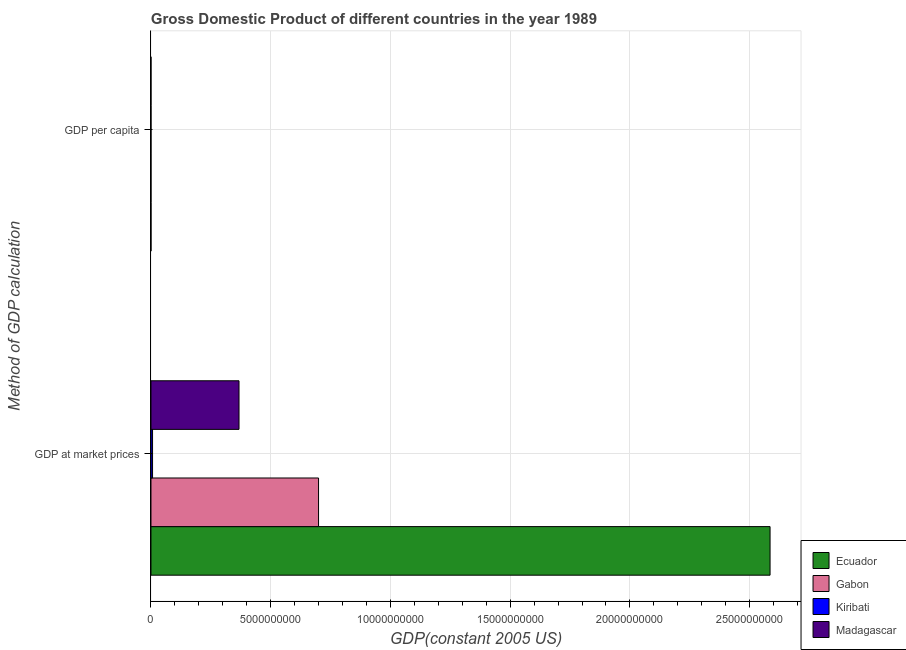How many groups of bars are there?
Make the answer very short. 2. Are the number of bars per tick equal to the number of legend labels?
Keep it short and to the point. Yes. What is the label of the 2nd group of bars from the top?
Your answer should be compact. GDP at market prices. What is the gdp at market prices in Madagascar?
Make the answer very short. 3.68e+09. Across all countries, what is the maximum gdp per capita?
Offer a terse response. 7552.38. Across all countries, what is the minimum gdp at market prices?
Give a very brief answer. 6.62e+07. In which country was the gdp at market prices maximum?
Your answer should be very brief. Ecuador. In which country was the gdp at market prices minimum?
Make the answer very short. Kiribati. What is the total gdp at market prices in the graph?
Your answer should be compact. 3.66e+1. What is the difference between the gdp per capita in Madagascar and that in Ecuador?
Your answer should be very brief. -2262.99. What is the difference between the gdp at market prices in Madagascar and the gdp per capita in Kiribati?
Give a very brief answer. 3.68e+09. What is the average gdp at market prices per country?
Your answer should be very brief. 9.15e+09. What is the difference between the gdp at market prices and gdp per capita in Gabon?
Keep it short and to the point. 7.00e+09. What is the ratio of the gdp per capita in Ecuador to that in Gabon?
Offer a terse response. 0.34. Is the gdp per capita in Madagascar less than that in Kiribati?
Provide a short and direct response. Yes. In how many countries, is the gdp per capita greater than the average gdp per capita taken over all countries?
Provide a short and direct response. 1. What does the 3rd bar from the top in GDP at market prices represents?
Your answer should be compact. Gabon. What does the 2nd bar from the bottom in GDP per capita represents?
Keep it short and to the point. Gabon. How many bars are there?
Your response must be concise. 8. Are all the bars in the graph horizontal?
Offer a terse response. Yes. What is the difference between two consecutive major ticks on the X-axis?
Make the answer very short. 5.00e+09. Are the values on the major ticks of X-axis written in scientific E-notation?
Your answer should be compact. No. Does the graph contain any zero values?
Give a very brief answer. No. Where does the legend appear in the graph?
Your answer should be very brief. Bottom right. How are the legend labels stacked?
Provide a succinct answer. Vertical. What is the title of the graph?
Provide a succinct answer. Gross Domestic Product of different countries in the year 1989. What is the label or title of the X-axis?
Offer a very short reply. GDP(constant 2005 US). What is the label or title of the Y-axis?
Offer a very short reply. Method of GDP calculation. What is the GDP(constant 2005 US) of Ecuador in GDP at market prices?
Your answer should be very brief. 2.59e+1. What is the GDP(constant 2005 US) in Gabon in GDP at market prices?
Offer a terse response. 7.00e+09. What is the GDP(constant 2005 US) in Kiribati in GDP at market prices?
Make the answer very short. 6.62e+07. What is the GDP(constant 2005 US) in Madagascar in GDP at market prices?
Ensure brevity in your answer.  3.68e+09. What is the GDP(constant 2005 US) in Ecuador in GDP per capita?
Give a very brief answer. 2591.15. What is the GDP(constant 2005 US) in Gabon in GDP per capita?
Provide a short and direct response. 7552.38. What is the GDP(constant 2005 US) of Kiribati in GDP per capita?
Your response must be concise. 934.01. What is the GDP(constant 2005 US) of Madagascar in GDP per capita?
Offer a terse response. 328.16. Across all Method of GDP calculation, what is the maximum GDP(constant 2005 US) of Ecuador?
Provide a succinct answer. 2.59e+1. Across all Method of GDP calculation, what is the maximum GDP(constant 2005 US) of Gabon?
Provide a short and direct response. 7.00e+09. Across all Method of GDP calculation, what is the maximum GDP(constant 2005 US) of Kiribati?
Ensure brevity in your answer.  6.62e+07. Across all Method of GDP calculation, what is the maximum GDP(constant 2005 US) in Madagascar?
Ensure brevity in your answer.  3.68e+09. Across all Method of GDP calculation, what is the minimum GDP(constant 2005 US) in Ecuador?
Offer a terse response. 2591.15. Across all Method of GDP calculation, what is the minimum GDP(constant 2005 US) in Gabon?
Keep it short and to the point. 7552.38. Across all Method of GDP calculation, what is the minimum GDP(constant 2005 US) of Kiribati?
Provide a succinct answer. 934.01. Across all Method of GDP calculation, what is the minimum GDP(constant 2005 US) in Madagascar?
Your answer should be compact. 328.16. What is the total GDP(constant 2005 US) of Ecuador in the graph?
Give a very brief answer. 2.59e+1. What is the total GDP(constant 2005 US) of Gabon in the graph?
Provide a short and direct response. 7.00e+09. What is the total GDP(constant 2005 US) in Kiribati in the graph?
Offer a terse response. 6.62e+07. What is the total GDP(constant 2005 US) in Madagascar in the graph?
Offer a terse response. 3.68e+09. What is the difference between the GDP(constant 2005 US) in Ecuador in GDP at market prices and that in GDP per capita?
Your answer should be compact. 2.59e+1. What is the difference between the GDP(constant 2005 US) of Gabon in GDP at market prices and that in GDP per capita?
Ensure brevity in your answer.  7.00e+09. What is the difference between the GDP(constant 2005 US) of Kiribati in GDP at market prices and that in GDP per capita?
Your response must be concise. 6.62e+07. What is the difference between the GDP(constant 2005 US) in Madagascar in GDP at market prices and that in GDP per capita?
Offer a very short reply. 3.68e+09. What is the difference between the GDP(constant 2005 US) of Ecuador in GDP at market prices and the GDP(constant 2005 US) of Gabon in GDP per capita?
Ensure brevity in your answer.  2.59e+1. What is the difference between the GDP(constant 2005 US) of Ecuador in GDP at market prices and the GDP(constant 2005 US) of Kiribati in GDP per capita?
Provide a short and direct response. 2.59e+1. What is the difference between the GDP(constant 2005 US) in Ecuador in GDP at market prices and the GDP(constant 2005 US) in Madagascar in GDP per capita?
Provide a succinct answer. 2.59e+1. What is the difference between the GDP(constant 2005 US) in Gabon in GDP at market prices and the GDP(constant 2005 US) in Kiribati in GDP per capita?
Make the answer very short. 7.00e+09. What is the difference between the GDP(constant 2005 US) of Gabon in GDP at market prices and the GDP(constant 2005 US) of Madagascar in GDP per capita?
Provide a succinct answer. 7.00e+09. What is the difference between the GDP(constant 2005 US) in Kiribati in GDP at market prices and the GDP(constant 2005 US) in Madagascar in GDP per capita?
Make the answer very short. 6.62e+07. What is the average GDP(constant 2005 US) of Ecuador per Method of GDP calculation?
Ensure brevity in your answer.  1.29e+1. What is the average GDP(constant 2005 US) in Gabon per Method of GDP calculation?
Keep it short and to the point. 3.50e+09. What is the average GDP(constant 2005 US) of Kiribati per Method of GDP calculation?
Give a very brief answer. 3.31e+07. What is the average GDP(constant 2005 US) of Madagascar per Method of GDP calculation?
Offer a terse response. 1.84e+09. What is the difference between the GDP(constant 2005 US) in Ecuador and GDP(constant 2005 US) in Gabon in GDP at market prices?
Keep it short and to the point. 1.89e+1. What is the difference between the GDP(constant 2005 US) of Ecuador and GDP(constant 2005 US) of Kiribati in GDP at market prices?
Provide a short and direct response. 2.58e+1. What is the difference between the GDP(constant 2005 US) in Ecuador and GDP(constant 2005 US) in Madagascar in GDP at market prices?
Provide a succinct answer. 2.22e+1. What is the difference between the GDP(constant 2005 US) in Gabon and GDP(constant 2005 US) in Kiribati in GDP at market prices?
Provide a short and direct response. 6.93e+09. What is the difference between the GDP(constant 2005 US) in Gabon and GDP(constant 2005 US) in Madagascar in GDP at market prices?
Provide a short and direct response. 3.32e+09. What is the difference between the GDP(constant 2005 US) of Kiribati and GDP(constant 2005 US) of Madagascar in GDP at market prices?
Provide a succinct answer. -3.61e+09. What is the difference between the GDP(constant 2005 US) in Ecuador and GDP(constant 2005 US) in Gabon in GDP per capita?
Offer a very short reply. -4961.23. What is the difference between the GDP(constant 2005 US) in Ecuador and GDP(constant 2005 US) in Kiribati in GDP per capita?
Your answer should be compact. 1657.14. What is the difference between the GDP(constant 2005 US) in Ecuador and GDP(constant 2005 US) in Madagascar in GDP per capita?
Your answer should be compact. 2262.99. What is the difference between the GDP(constant 2005 US) of Gabon and GDP(constant 2005 US) of Kiribati in GDP per capita?
Make the answer very short. 6618.38. What is the difference between the GDP(constant 2005 US) in Gabon and GDP(constant 2005 US) in Madagascar in GDP per capita?
Provide a succinct answer. 7224.22. What is the difference between the GDP(constant 2005 US) of Kiribati and GDP(constant 2005 US) of Madagascar in GDP per capita?
Your answer should be compact. 605.84. What is the ratio of the GDP(constant 2005 US) in Ecuador in GDP at market prices to that in GDP per capita?
Your response must be concise. 9.98e+06. What is the ratio of the GDP(constant 2005 US) in Gabon in GDP at market prices to that in GDP per capita?
Your response must be concise. 9.27e+05. What is the ratio of the GDP(constant 2005 US) in Kiribati in GDP at market prices to that in GDP per capita?
Keep it short and to the point. 7.09e+04. What is the ratio of the GDP(constant 2005 US) in Madagascar in GDP at market prices to that in GDP per capita?
Your response must be concise. 1.12e+07. What is the difference between the highest and the second highest GDP(constant 2005 US) of Ecuador?
Provide a short and direct response. 2.59e+1. What is the difference between the highest and the second highest GDP(constant 2005 US) in Gabon?
Offer a terse response. 7.00e+09. What is the difference between the highest and the second highest GDP(constant 2005 US) of Kiribati?
Ensure brevity in your answer.  6.62e+07. What is the difference between the highest and the second highest GDP(constant 2005 US) of Madagascar?
Provide a short and direct response. 3.68e+09. What is the difference between the highest and the lowest GDP(constant 2005 US) of Ecuador?
Ensure brevity in your answer.  2.59e+1. What is the difference between the highest and the lowest GDP(constant 2005 US) of Gabon?
Offer a very short reply. 7.00e+09. What is the difference between the highest and the lowest GDP(constant 2005 US) of Kiribati?
Your response must be concise. 6.62e+07. What is the difference between the highest and the lowest GDP(constant 2005 US) in Madagascar?
Give a very brief answer. 3.68e+09. 